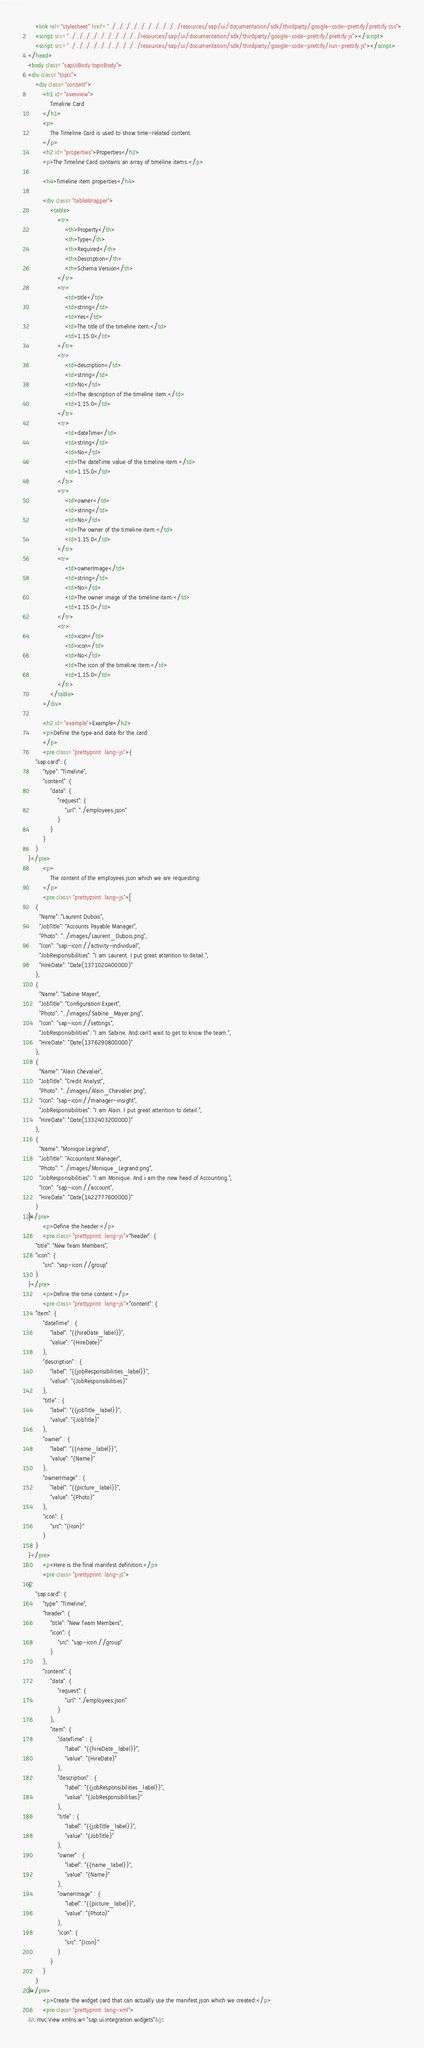Convert code to text. <code><loc_0><loc_0><loc_500><loc_500><_HTML_>	<link rel="stylesheet" href="../../../../../../../../../../resources/sap/ui/documentation/sdk/thirdparty/google-code-prettify/prettify.css">
	<script src="../../../../../../../../../../resources/sap/ui/documentation/sdk/thirdparty/google-code-prettify/prettify.js"></script>
	<script src="../../../../../../../../../../resources/sap/ui/documentation/sdk/thirdparty/google-code-prettify/run-prettify.js"></script>
</head>
<body class="sapUiBody topicBody">
<div class="topic">
	<div class="content">
		<h1 id="overview">
			Timeline Card
		</h1>
		<p>
			The Timeline Card is used to show time-related content.
		</p>
		<h2 id="properties">Properties</h2>
		<p>The Timeline Card contains an array of timeline items.</p>

		<h4>Timeline item properties</h4>

		<div class="tableWrapper">
			<table>
				<tr>
					<th>Property</th>
					<th>Type</th>
					<th>Required</th>
					<th>Description</th>
					<th>Schema Version</th>
				</tr>
				<tr>
					<td>title</td>
					<td>string</td>
					<td>Yes</td>
					<td>The title of the timeline item.</td>
					<td>1.15.0</td>
				</tr>
				<tr>
					<td>description</td>
					<td>string</td>
					<td>No</td>
					<td>The description of the timeline item.</td>
					<td>1.15.0</td>
				</tr>
				<tr>
					<td>dateTime</td>
					<td>string</td>
					<td>No</td>
					<td>The dateTime value of the timeline item.</td>
					<td>1.15.0</td>
				</tr>
				<tr>
					<td>owner</td>
					<td>string</td>
					<td>No</td>
					<td>The owner of the timeline item.</td>
					<td>1.15.0</td>
				</tr>
				<tr>
					<td>ownerImage</td>
					<td>string</td>
					<td>No</td>
					<td>The owner image of the timeline item.</td>
					<td>1.15.0</td>
				</tr>
				<tr>
					<td>icon</td>
					<td>icon</td>
					<td>No</td>
					<td>The icon of the timeline item.</td>
					<td>1.15.0</td>
				</tr>
			</table>
		</div>

		<h2 id="example">Example</h2>
		<p>Define the type and data for the card:
		</p>
		<pre class="prettyprint  lang-js">{
	"sap.card": {
		"type": "Timeline",
		"content" :{
			"data": {
				"request": {
					"url": "./employees.json"
				}
			}
		}
	}
}</pre>
		<p>
			The content of the employees.json which we are requesting:
		</p>
		<pre class="prettyprint  lang-js">[
	{
	  "Name": "Laurent Dubois",
	  "JobTitle": "Accounts Payable Manager",
	  "Photo": "../images/Laurent_Dubois.png",
	  "Icon": "sap-icon://activity-individual",
	  "JobResponsibilities": "I am Laurent. I put great attention to detail.",
	  "HireDate": "Date(1371020400000)"
	},
	{
	  "Name": "Sabine Mayer",
	  "JobTitle": "Configuration Expert",
	  "Photo": "../images/Sabine_Mayer.png",
	  "Icon": "sap-icon://settings",
	  "JobResponsibilities": "I am Sabine. And can't wait to get to know the team.",
	  "HireDate": "Date(1376290800000)"
	},
	{
	  "Name": "Alain Chevalier",
	  "JobTitle": "Credit Analyst",
	  "Photo": "../images/Alain_Chevalier.png",
	  "Icon": "sap-icon://manager-insight",
	  "JobResponsibilities": "I am Alain. I put great attention to detail.",
	  "HireDate": "Date(1332403200000)"
	},
	{
	  "Name": "Monique Legrand",
	  "JobTitle": "Accountant Manager",
	  "Photo": "../images/Monique_Legrand.png",
	  "JobResponsibilities": "I am Monique. And i am the new head of Accounting.",
	  "Icon": "sap-icon://account",
	  "HireDate": "Date(1422777600000)"
	}
]</pre>
		<p>Define the header:</p>
		<pre class="prettyprint  lang-js">"header": {
	"title": "New Team Members",
	"icon": {
		"src": "sap-icon://group"
	}
}</pre>
		<p>Define the time content:</p>
		<pre class="prettyprint  lang-js">"content": {
	"item": {
		"dateTime" : {
			"label": "{{hireDate_label}}",
			"value": "{HireDate}"
		},
		"description" : {
			"label": "{{jobResponsibilities_label}}",
			"value": "{JobResponsibilities}"
		},
		"title" : {
			"label": "{{jobTitle_label}}",
			"value": "{JobTitle}"
		},
		"owner" : {
			"label": "{{name_label}}",
			"value": "{Name}"
		},
		"ownerImage" : {
			"label": "{{picture_label}}",
			"value": "{Photo}"
		},
		"icon": {
			"src": "{Icon}"
		}
	}
}</pre>
		<p>Here is the final manifest definition:</p>
		<pre class="prettyprint  lang-js">
{
	"sap.card": {
		"type": "Timeline",
		"header": {
			"title": "New Team Members",
			"icon": {
				"src": "sap-icon://group"
			}
		},
		"content": {
			"data": {
				"request": {
					"url": "./employees.json"
				}
			},
			"item": {
				"dateTime" : {
					"label": "{{hireDate_label}}",
					"value": "{HireDate}"
				},
				"description" : {
					"label": "{{jobResponsibilities_label}}",
					"value": "{JobResponsibilities}"
				},
				"title" : {
					"label": "{{jobTitle_label}}",
					"value": "{JobTitle}"
				},
				"owner" : {
					"label": "{{name_label}}",
					"value": "{Name}"
				},
				"ownerImage" : {
					"label": "{{picture_label}}",
					"value": "{Photo}"
				},
				"icon": {
					"src": "{Icon}"
				}
			}
		}
	}
}</pre>
		<p>Create the widget card that can actually use the manifest.json which we created:</p>
		<pre class="prettyprint  lang-xml">
&lt;mvc:View xmlns:w="sap.ui.integration.widgets"&gt;</code> 